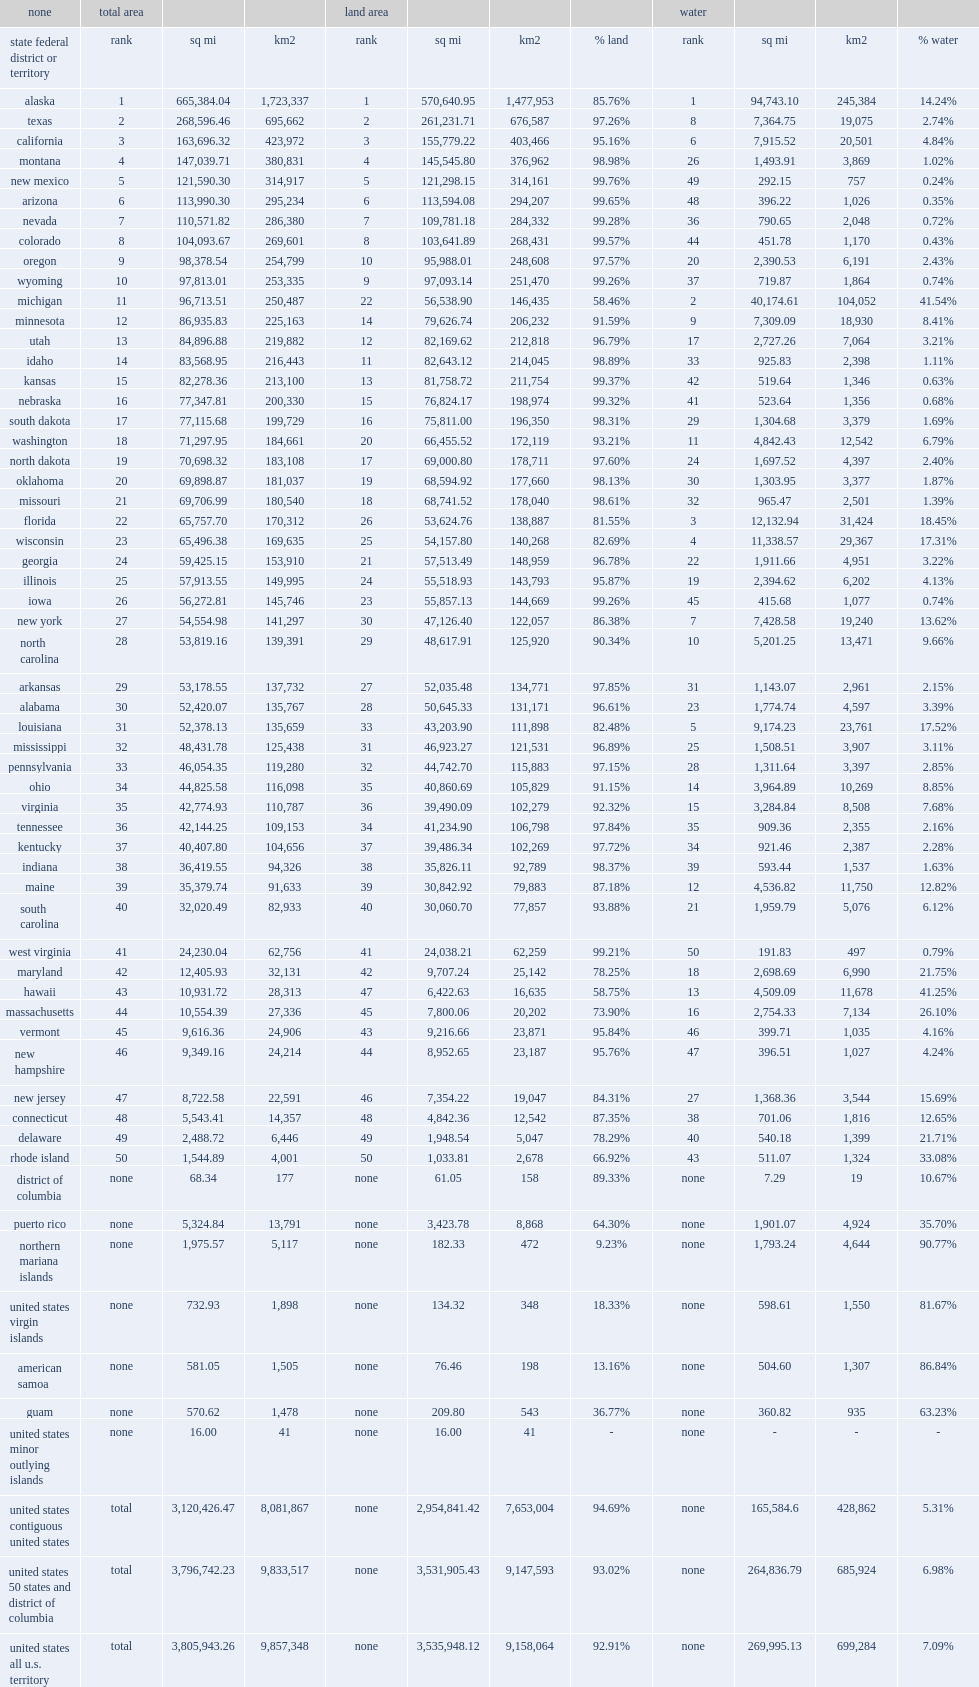What is idaho's rank in the u.s. states? 14.0. 